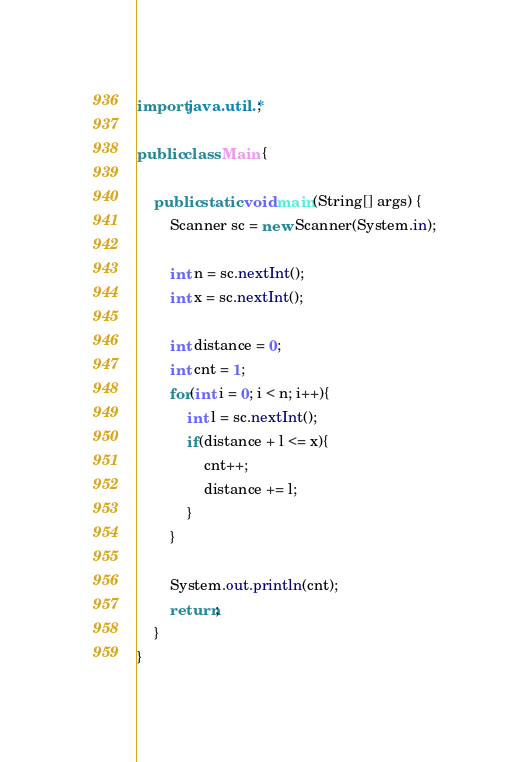<code> <loc_0><loc_0><loc_500><loc_500><_Java_>import java.util.*;

public class Main {

    public static void main(String[] args) {
        Scanner sc = new Scanner(System.in);

        int n = sc.nextInt();
        int x = sc.nextInt();

        int distance = 0;
        int cnt = 1;
        for(int i = 0; i < n; i++){
            int l = sc.nextInt();
            if(distance + l <= x){
                cnt++;
                distance += l;
            }
        }

        System.out.println(cnt);
        return;
    }
}</code> 